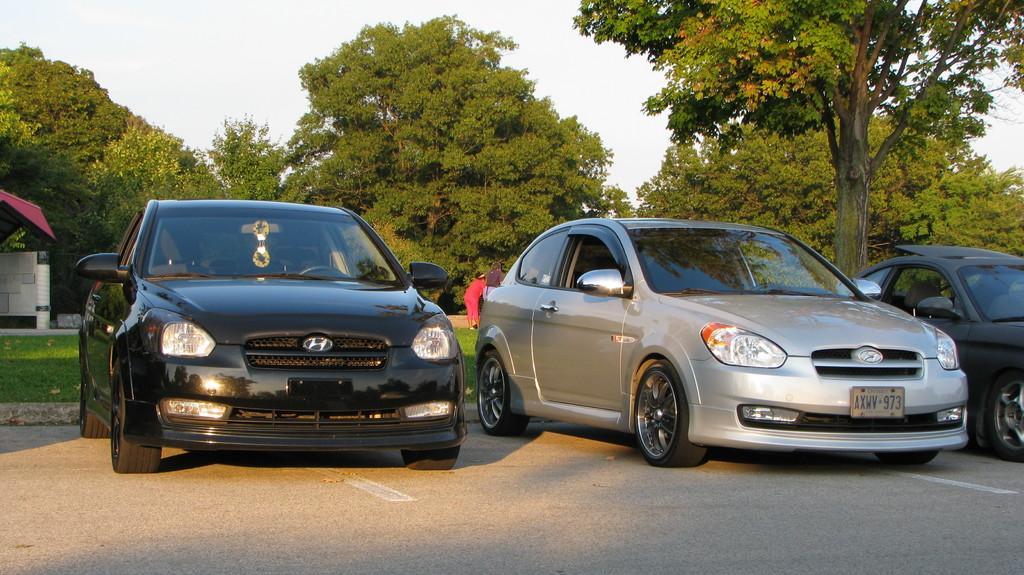Describe this image in one or two sentences. In the picture I can see vehicles on the road. In the background I can see a person, trees, the grass, the sky and some other objects on the ground. 